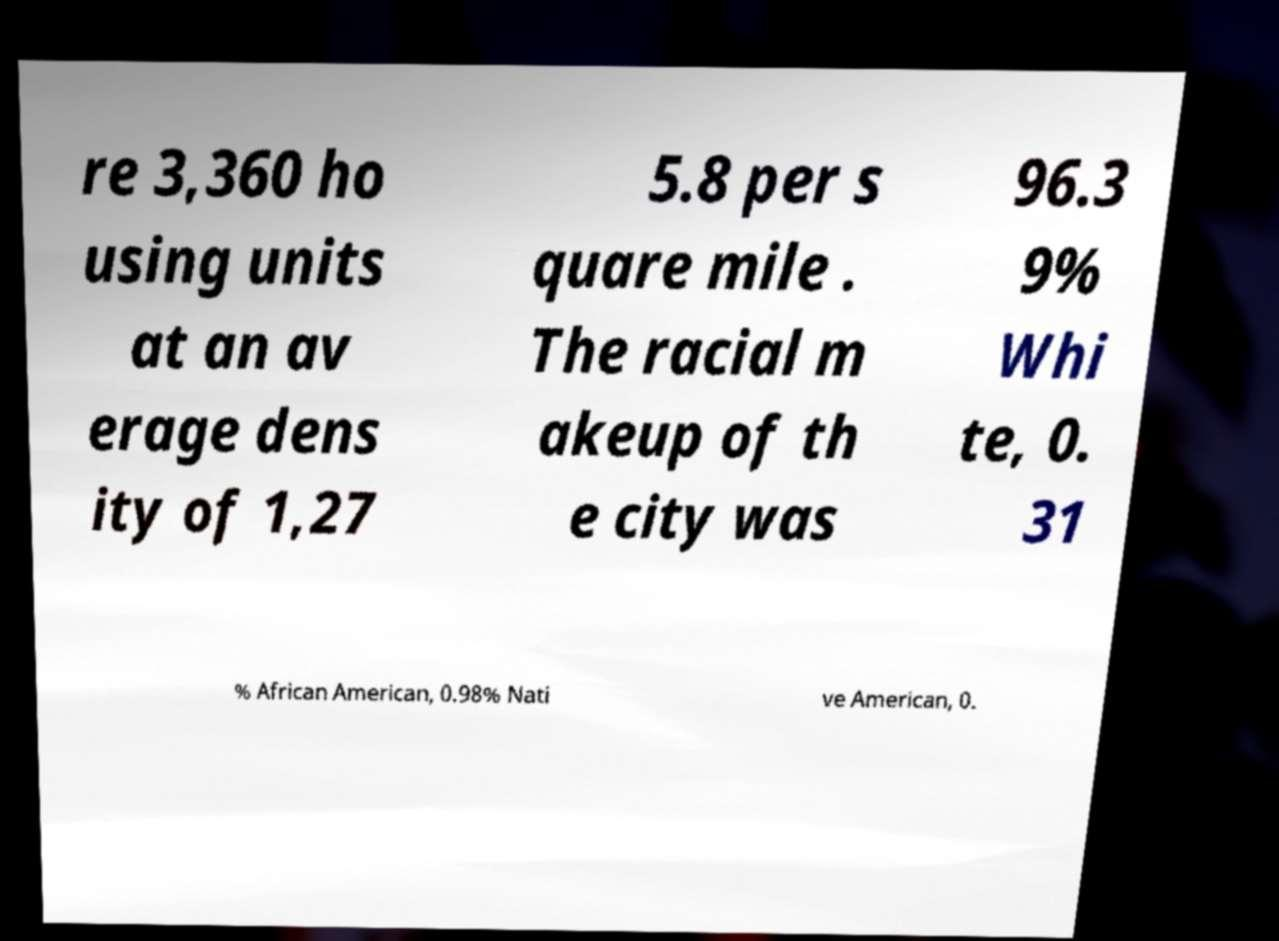Please read and relay the text visible in this image. What does it say? re 3,360 ho using units at an av erage dens ity of 1,27 5.8 per s quare mile . The racial m akeup of th e city was 96.3 9% Whi te, 0. 31 % African American, 0.98% Nati ve American, 0. 